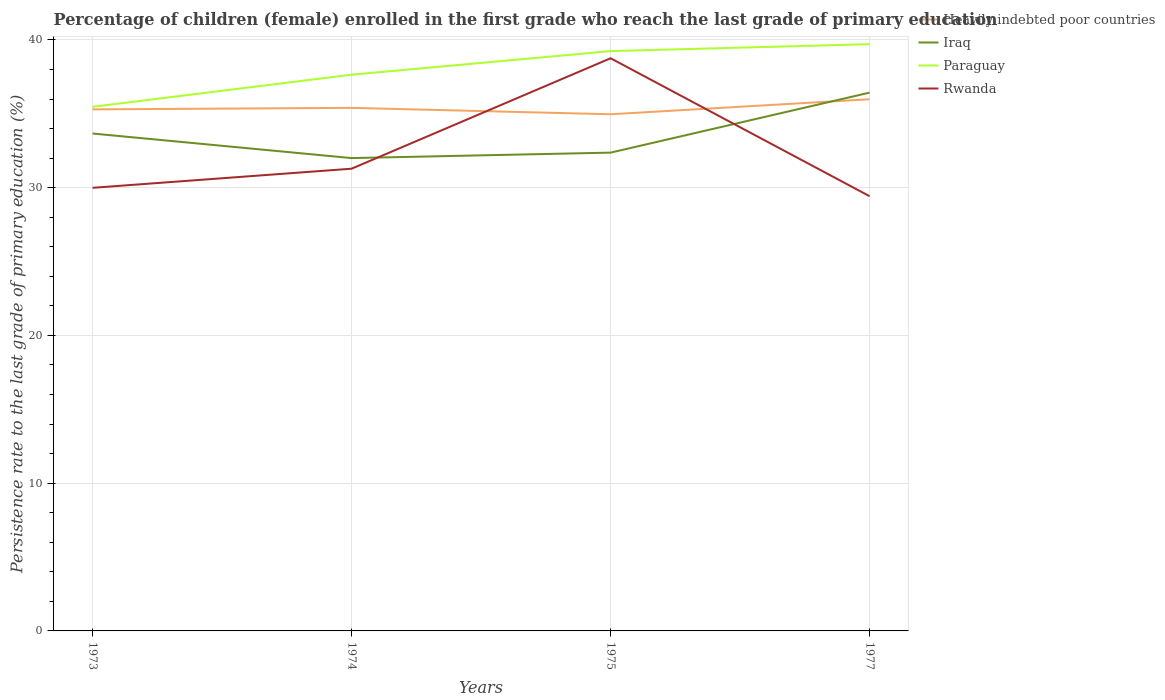Does the line corresponding to Iraq intersect with the line corresponding to Paraguay?
Offer a very short reply. No. Across all years, what is the maximum persistence rate of children in Paraguay?
Keep it short and to the point. 35.47. In which year was the persistence rate of children in Iraq maximum?
Your answer should be compact. 1974. What is the total persistence rate of children in Paraguay in the graph?
Ensure brevity in your answer.  -2.06. What is the difference between the highest and the second highest persistence rate of children in Iraq?
Your response must be concise. 4.43. Is the persistence rate of children in Rwanda strictly greater than the persistence rate of children in Iraq over the years?
Provide a succinct answer. No. Are the values on the major ticks of Y-axis written in scientific E-notation?
Keep it short and to the point. No. Does the graph contain grids?
Your answer should be very brief. Yes. Where does the legend appear in the graph?
Ensure brevity in your answer.  Top right. How are the legend labels stacked?
Make the answer very short. Vertical. What is the title of the graph?
Your answer should be compact. Percentage of children (female) enrolled in the first grade who reach the last grade of primary education. Does "Arab World" appear as one of the legend labels in the graph?
Offer a terse response. No. What is the label or title of the X-axis?
Provide a succinct answer. Years. What is the label or title of the Y-axis?
Ensure brevity in your answer.  Persistence rate to the last grade of primary education (%). What is the Persistence rate to the last grade of primary education (%) of Heavily indebted poor countries in 1973?
Offer a very short reply. 35.3. What is the Persistence rate to the last grade of primary education (%) of Iraq in 1973?
Provide a short and direct response. 33.66. What is the Persistence rate to the last grade of primary education (%) in Paraguay in 1973?
Offer a very short reply. 35.47. What is the Persistence rate to the last grade of primary education (%) of Rwanda in 1973?
Make the answer very short. 29.99. What is the Persistence rate to the last grade of primary education (%) of Heavily indebted poor countries in 1974?
Offer a terse response. 35.4. What is the Persistence rate to the last grade of primary education (%) in Iraq in 1974?
Provide a short and direct response. 32. What is the Persistence rate to the last grade of primary education (%) of Paraguay in 1974?
Give a very brief answer. 37.65. What is the Persistence rate to the last grade of primary education (%) of Rwanda in 1974?
Keep it short and to the point. 31.28. What is the Persistence rate to the last grade of primary education (%) of Heavily indebted poor countries in 1975?
Offer a very short reply. 34.97. What is the Persistence rate to the last grade of primary education (%) of Iraq in 1975?
Keep it short and to the point. 32.37. What is the Persistence rate to the last grade of primary education (%) in Paraguay in 1975?
Your response must be concise. 39.24. What is the Persistence rate to the last grade of primary education (%) in Rwanda in 1975?
Ensure brevity in your answer.  38.76. What is the Persistence rate to the last grade of primary education (%) of Heavily indebted poor countries in 1977?
Provide a short and direct response. 35.98. What is the Persistence rate to the last grade of primary education (%) in Iraq in 1977?
Your response must be concise. 36.43. What is the Persistence rate to the last grade of primary education (%) in Paraguay in 1977?
Your answer should be compact. 39.71. What is the Persistence rate to the last grade of primary education (%) in Rwanda in 1977?
Ensure brevity in your answer.  29.42. Across all years, what is the maximum Persistence rate to the last grade of primary education (%) in Heavily indebted poor countries?
Keep it short and to the point. 35.98. Across all years, what is the maximum Persistence rate to the last grade of primary education (%) in Iraq?
Your answer should be compact. 36.43. Across all years, what is the maximum Persistence rate to the last grade of primary education (%) in Paraguay?
Make the answer very short. 39.71. Across all years, what is the maximum Persistence rate to the last grade of primary education (%) in Rwanda?
Keep it short and to the point. 38.76. Across all years, what is the minimum Persistence rate to the last grade of primary education (%) in Heavily indebted poor countries?
Make the answer very short. 34.97. Across all years, what is the minimum Persistence rate to the last grade of primary education (%) in Iraq?
Your answer should be compact. 32. Across all years, what is the minimum Persistence rate to the last grade of primary education (%) of Paraguay?
Keep it short and to the point. 35.47. Across all years, what is the minimum Persistence rate to the last grade of primary education (%) of Rwanda?
Keep it short and to the point. 29.42. What is the total Persistence rate to the last grade of primary education (%) of Heavily indebted poor countries in the graph?
Provide a succinct answer. 141.65. What is the total Persistence rate to the last grade of primary education (%) of Iraq in the graph?
Make the answer very short. 134.47. What is the total Persistence rate to the last grade of primary education (%) of Paraguay in the graph?
Provide a succinct answer. 152.07. What is the total Persistence rate to the last grade of primary education (%) in Rwanda in the graph?
Provide a succinct answer. 129.45. What is the difference between the Persistence rate to the last grade of primary education (%) of Heavily indebted poor countries in 1973 and that in 1974?
Your answer should be compact. -0.1. What is the difference between the Persistence rate to the last grade of primary education (%) of Iraq in 1973 and that in 1974?
Provide a succinct answer. 1.66. What is the difference between the Persistence rate to the last grade of primary education (%) of Paraguay in 1973 and that in 1974?
Keep it short and to the point. -2.18. What is the difference between the Persistence rate to the last grade of primary education (%) of Rwanda in 1973 and that in 1974?
Make the answer very short. -1.29. What is the difference between the Persistence rate to the last grade of primary education (%) of Heavily indebted poor countries in 1973 and that in 1975?
Make the answer very short. 0.33. What is the difference between the Persistence rate to the last grade of primary education (%) in Iraq in 1973 and that in 1975?
Provide a succinct answer. 1.29. What is the difference between the Persistence rate to the last grade of primary education (%) of Paraguay in 1973 and that in 1975?
Offer a terse response. -3.77. What is the difference between the Persistence rate to the last grade of primary education (%) in Rwanda in 1973 and that in 1975?
Your response must be concise. -8.77. What is the difference between the Persistence rate to the last grade of primary education (%) in Heavily indebted poor countries in 1973 and that in 1977?
Your answer should be very brief. -0.69. What is the difference between the Persistence rate to the last grade of primary education (%) in Iraq in 1973 and that in 1977?
Provide a short and direct response. -2.77. What is the difference between the Persistence rate to the last grade of primary education (%) in Paraguay in 1973 and that in 1977?
Provide a short and direct response. -4.24. What is the difference between the Persistence rate to the last grade of primary education (%) in Rwanda in 1973 and that in 1977?
Make the answer very short. 0.57. What is the difference between the Persistence rate to the last grade of primary education (%) in Heavily indebted poor countries in 1974 and that in 1975?
Your answer should be compact. 0.43. What is the difference between the Persistence rate to the last grade of primary education (%) of Iraq in 1974 and that in 1975?
Give a very brief answer. -0.37. What is the difference between the Persistence rate to the last grade of primary education (%) in Paraguay in 1974 and that in 1975?
Offer a very short reply. -1.59. What is the difference between the Persistence rate to the last grade of primary education (%) of Rwanda in 1974 and that in 1975?
Provide a short and direct response. -7.47. What is the difference between the Persistence rate to the last grade of primary education (%) in Heavily indebted poor countries in 1974 and that in 1977?
Offer a terse response. -0.58. What is the difference between the Persistence rate to the last grade of primary education (%) in Iraq in 1974 and that in 1977?
Provide a succinct answer. -4.43. What is the difference between the Persistence rate to the last grade of primary education (%) in Paraguay in 1974 and that in 1977?
Provide a succinct answer. -2.06. What is the difference between the Persistence rate to the last grade of primary education (%) in Rwanda in 1974 and that in 1977?
Provide a succinct answer. 1.86. What is the difference between the Persistence rate to the last grade of primary education (%) of Heavily indebted poor countries in 1975 and that in 1977?
Provide a short and direct response. -1.02. What is the difference between the Persistence rate to the last grade of primary education (%) of Iraq in 1975 and that in 1977?
Keep it short and to the point. -4.06. What is the difference between the Persistence rate to the last grade of primary education (%) of Paraguay in 1975 and that in 1977?
Give a very brief answer. -0.47. What is the difference between the Persistence rate to the last grade of primary education (%) of Rwanda in 1975 and that in 1977?
Provide a short and direct response. 9.34. What is the difference between the Persistence rate to the last grade of primary education (%) in Heavily indebted poor countries in 1973 and the Persistence rate to the last grade of primary education (%) in Iraq in 1974?
Offer a terse response. 3.3. What is the difference between the Persistence rate to the last grade of primary education (%) of Heavily indebted poor countries in 1973 and the Persistence rate to the last grade of primary education (%) of Paraguay in 1974?
Make the answer very short. -2.35. What is the difference between the Persistence rate to the last grade of primary education (%) in Heavily indebted poor countries in 1973 and the Persistence rate to the last grade of primary education (%) in Rwanda in 1974?
Give a very brief answer. 4.02. What is the difference between the Persistence rate to the last grade of primary education (%) of Iraq in 1973 and the Persistence rate to the last grade of primary education (%) of Paraguay in 1974?
Your answer should be very brief. -3.98. What is the difference between the Persistence rate to the last grade of primary education (%) of Iraq in 1973 and the Persistence rate to the last grade of primary education (%) of Rwanda in 1974?
Provide a short and direct response. 2.38. What is the difference between the Persistence rate to the last grade of primary education (%) in Paraguay in 1973 and the Persistence rate to the last grade of primary education (%) in Rwanda in 1974?
Your answer should be very brief. 4.19. What is the difference between the Persistence rate to the last grade of primary education (%) in Heavily indebted poor countries in 1973 and the Persistence rate to the last grade of primary education (%) in Iraq in 1975?
Make the answer very short. 2.93. What is the difference between the Persistence rate to the last grade of primary education (%) of Heavily indebted poor countries in 1973 and the Persistence rate to the last grade of primary education (%) of Paraguay in 1975?
Give a very brief answer. -3.94. What is the difference between the Persistence rate to the last grade of primary education (%) in Heavily indebted poor countries in 1973 and the Persistence rate to the last grade of primary education (%) in Rwanda in 1975?
Offer a very short reply. -3.46. What is the difference between the Persistence rate to the last grade of primary education (%) in Iraq in 1973 and the Persistence rate to the last grade of primary education (%) in Paraguay in 1975?
Ensure brevity in your answer.  -5.58. What is the difference between the Persistence rate to the last grade of primary education (%) of Iraq in 1973 and the Persistence rate to the last grade of primary education (%) of Rwanda in 1975?
Give a very brief answer. -5.09. What is the difference between the Persistence rate to the last grade of primary education (%) of Paraguay in 1973 and the Persistence rate to the last grade of primary education (%) of Rwanda in 1975?
Offer a very short reply. -3.29. What is the difference between the Persistence rate to the last grade of primary education (%) of Heavily indebted poor countries in 1973 and the Persistence rate to the last grade of primary education (%) of Iraq in 1977?
Ensure brevity in your answer.  -1.13. What is the difference between the Persistence rate to the last grade of primary education (%) of Heavily indebted poor countries in 1973 and the Persistence rate to the last grade of primary education (%) of Paraguay in 1977?
Provide a succinct answer. -4.41. What is the difference between the Persistence rate to the last grade of primary education (%) in Heavily indebted poor countries in 1973 and the Persistence rate to the last grade of primary education (%) in Rwanda in 1977?
Provide a short and direct response. 5.88. What is the difference between the Persistence rate to the last grade of primary education (%) in Iraq in 1973 and the Persistence rate to the last grade of primary education (%) in Paraguay in 1977?
Offer a very short reply. -6.05. What is the difference between the Persistence rate to the last grade of primary education (%) of Iraq in 1973 and the Persistence rate to the last grade of primary education (%) of Rwanda in 1977?
Your answer should be very brief. 4.24. What is the difference between the Persistence rate to the last grade of primary education (%) of Paraguay in 1973 and the Persistence rate to the last grade of primary education (%) of Rwanda in 1977?
Keep it short and to the point. 6.05. What is the difference between the Persistence rate to the last grade of primary education (%) of Heavily indebted poor countries in 1974 and the Persistence rate to the last grade of primary education (%) of Iraq in 1975?
Make the answer very short. 3.03. What is the difference between the Persistence rate to the last grade of primary education (%) in Heavily indebted poor countries in 1974 and the Persistence rate to the last grade of primary education (%) in Paraguay in 1975?
Provide a succinct answer. -3.84. What is the difference between the Persistence rate to the last grade of primary education (%) of Heavily indebted poor countries in 1974 and the Persistence rate to the last grade of primary education (%) of Rwanda in 1975?
Offer a very short reply. -3.36. What is the difference between the Persistence rate to the last grade of primary education (%) in Iraq in 1974 and the Persistence rate to the last grade of primary education (%) in Paraguay in 1975?
Make the answer very short. -7.24. What is the difference between the Persistence rate to the last grade of primary education (%) of Iraq in 1974 and the Persistence rate to the last grade of primary education (%) of Rwanda in 1975?
Your answer should be compact. -6.76. What is the difference between the Persistence rate to the last grade of primary education (%) of Paraguay in 1974 and the Persistence rate to the last grade of primary education (%) of Rwanda in 1975?
Provide a succinct answer. -1.11. What is the difference between the Persistence rate to the last grade of primary education (%) of Heavily indebted poor countries in 1974 and the Persistence rate to the last grade of primary education (%) of Iraq in 1977?
Your response must be concise. -1.03. What is the difference between the Persistence rate to the last grade of primary education (%) in Heavily indebted poor countries in 1974 and the Persistence rate to the last grade of primary education (%) in Paraguay in 1977?
Provide a succinct answer. -4.31. What is the difference between the Persistence rate to the last grade of primary education (%) of Heavily indebted poor countries in 1974 and the Persistence rate to the last grade of primary education (%) of Rwanda in 1977?
Your response must be concise. 5.98. What is the difference between the Persistence rate to the last grade of primary education (%) in Iraq in 1974 and the Persistence rate to the last grade of primary education (%) in Paraguay in 1977?
Offer a terse response. -7.71. What is the difference between the Persistence rate to the last grade of primary education (%) in Iraq in 1974 and the Persistence rate to the last grade of primary education (%) in Rwanda in 1977?
Your answer should be very brief. 2.58. What is the difference between the Persistence rate to the last grade of primary education (%) of Paraguay in 1974 and the Persistence rate to the last grade of primary education (%) of Rwanda in 1977?
Provide a short and direct response. 8.22. What is the difference between the Persistence rate to the last grade of primary education (%) in Heavily indebted poor countries in 1975 and the Persistence rate to the last grade of primary education (%) in Iraq in 1977?
Make the answer very short. -1.47. What is the difference between the Persistence rate to the last grade of primary education (%) in Heavily indebted poor countries in 1975 and the Persistence rate to the last grade of primary education (%) in Paraguay in 1977?
Keep it short and to the point. -4.74. What is the difference between the Persistence rate to the last grade of primary education (%) of Heavily indebted poor countries in 1975 and the Persistence rate to the last grade of primary education (%) of Rwanda in 1977?
Give a very brief answer. 5.55. What is the difference between the Persistence rate to the last grade of primary education (%) in Iraq in 1975 and the Persistence rate to the last grade of primary education (%) in Paraguay in 1977?
Provide a succinct answer. -7.34. What is the difference between the Persistence rate to the last grade of primary education (%) of Iraq in 1975 and the Persistence rate to the last grade of primary education (%) of Rwanda in 1977?
Offer a terse response. 2.95. What is the difference between the Persistence rate to the last grade of primary education (%) of Paraguay in 1975 and the Persistence rate to the last grade of primary education (%) of Rwanda in 1977?
Your answer should be very brief. 9.82. What is the average Persistence rate to the last grade of primary education (%) in Heavily indebted poor countries per year?
Give a very brief answer. 35.41. What is the average Persistence rate to the last grade of primary education (%) of Iraq per year?
Make the answer very short. 33.62. What is the average Persistence rate to the last grade of primary education (%) in Paraguay per year?
Provide a succinct answer. 38.02. What is the average Persistence rate to the last grade of primary education (%) in Rwanda per year?
Provide a short and direct response. 32.36. In the year 1973, what is the difference between the Persistence rate to the last grade of primary education (%) in Heavily indebted poor countries and Persistence rate to the last grade of primary education (%) in Iraq?
Provide a short and direct response. 1.63. In the year 1973, what is the difference between the Persistence rate to the last grade of primary education (%) of Heavily indebted poor countries and Persistence rate to the last grade of primary education (%) of Paraguay?
Offer a terse response. -0.17. In the year 1973, what is the difference between the Persistence rate to the last grade of primary education (%) of Heavily indebted poor countries and Persistence rate to the last grade of primary education (%) of Rwanda?
Ensure brevity in your answer.  5.31. In the year 1973, what is the difference between the Persistence rate to the last grade of primary education (%) of Iraq and Persistence rate to the last grade of primary education (%) of Paraguay?
Keep it short and to the point. -1.81. In the year 1973, what is the difference between the Persistence rate to the last grade of primary education (%) in Iraq and Persistence rate to the last grade of primary education (%) in Rwanda?
Your answer should be very brief. 3.67. In the year 1973, what is the difference between the Persistence rate to the last grade of primary education (%) in Paraguay and Persistence rate to the last grade of primary education (%) in Rwanda?
Provide a succinct answer. 5.48. In the year 1974, what is the difference between the Persistence rate to the last grade of primary education (%) in Heavily indebted poor countries and Persistence rate to the last grade of primary education (%) in Iraq?
Ensure brevity in your answer.  3.4. In the year 1974, what is the difference between the Persistence rate to the last grade of primary education (%) in Heavily indebted poor countries and Persistence rate to the last grade of primary education (%) in Paraguay?
Your answer should be very brief. -2.25. In the year 1974, what is the difference between the Persistence rate to the last grade of primary education (%) of Heavily indebted poor countries and Persistence rate to the last grade of primary education (%) of Rwanda?
Provide a short and direct response. 4.12. In the year 1974, what is the difference between the Persistence rate to the last grade of primary education (%) of Iraq and Persistence rate to the last grade of primary education (%) of Paraguay?
Offer a terse response. -5.64. In the year 1974, what is the difference between the Persistence rate to the last grade of primary education (%) of Iraq and Persistence rate to the last grade of primary education (%) of Rwanda?
Offer a very short reply. 0.72. In the year 1974, what is the difference between the Persistence rate to the last grade of primary education (%) of Paraguay and Persistence rate to the last grade of primary education (%) of Rwanda?
Offer a very short reply. 6.36. In the year 1975, what is the difference between the Persistence rate to the last grade of primary education (%) of Heavily indebted poor countries and Persistence rate to the last grade of primary education (%) of Iraq?
Provide a short and direct response. 2.6. In the year 1975, what is the difference between the Persistence rate to the last grade of primary education (%) of Heavily indebted poor countries and Persistence rate to the last grade of primary education (%) of Paraguay?
Keep it short and to the point. -4.27. In the year 1975, what is the difference between the Persistence rate to the last grade of primary education (%) in Heavily indebted poor countries and Persistence rate to the last grade of primary education (%) in Rwanda?
Your answer should be compact. -3.79. In the year 1975, what is the difference between the Persistence rate to the last grade of primary education (%) of Iraq and Persistence rate to the last grade of primary education (%) of Paraguay?
Your answer should be compact. -6.87. In the year 1975, what is the difference between the Persistence rate to the last grade of primary education (%) in Iraq and Persistence rate to the last grade of primary education (%) in Rwanda?
Give a very brief answer. -6.39. In the year 1975, what is the difference between the Persistence rate to the last grade of primary education (%) of Paraguay and Persistence rate to the last grade of primary education (%) of Rwanda?
Your answer should be very brief. 0.48. In the year 1977, what is the difference between the Persistence rate to the last grade of primary education (%) in Heavily indebted poor countries and Persistence rate to the last grade of primary education (%) in Iraq?
Provide a succinct answer. -0.45. In the year 1977, what is the difference between the Persistence rate to the last grade of primary education (%) of Heavily indebted poor countries and Persistence rate to the last grade of primary education (%) of Paraguay?
Your answer should be compact. -3.73. In the year 1977, what is the difference between the Persistence rate to the last grade of primary education (%) of Heavily indebted poor countries and Persistence rate to the last grade of primary education (%) of Rwanda?
Offer a terse response. 6.56. In the year 1977, what is the difference between the Persistence rate to the last grade of primary education (%) of Iraq and Persistence rate to the last grade of primary education (%) of Paraguay?
Offer a very short reply. -3.28. In the year 1977, what is the difference between the Persistence rate to the last grade of primary education (%) in Iraq and Persistence rate to the last grade of primary education (%) in Rwanda?
Offer a terse response. 7.01. In the year 1977, what is the difference between the Persistence rate to the last grade of primary education (%) of Paraguay and Persistence rate to the last grade of primary education (%) of Rwanda?
Offer a very short reply. 10.29. What is the ratio of the Persistence rate to the last grade of primary education (%) in Heavily indebted poor countries in 1973 to that in 1974?
Provide a succinct answer. 1. What is the ratio of the Persistence rate to the last grade of primary education (%) in Iraq in 1973 to that in 1974?
Give a very brief answer. 1.05. What is the ratio of the Persistence rate to the last grade of primary education (%) in Paraguay in 1973 to that in 1974?
Ensure brevity in your answer.  0.94. What is the ratio of the Persistence rate to the last grade of primary education (%) of Rwanda in 1973 to that in 1974?
Your answer should be compact. 0.96. What is the ratio of the Persistence rate to the last grade of primary education (%) of Heavily indebted poor countries in 1973 to that in 1975?
Offer a terse response. 1.01. What is the ratio of the Persistence rate to the last grade of primary education (%) in Paraguay in 1973 to that in 1975?
Offer a terse response. 0.9. What is the ratio of the Persistence rate to the last grade of primary education (%) in Rwanda in 1973 to that in 1975?
Ensure brevity in your answer.  0.77. What is the ratio of the Persistence rate to the last grade of primary education (%) in Heavily indebted poor countries in 1973 to that in 1977?
Your answer should be compact. 0.98. What is the ratio of the Persistence rate to the last grade of primary education (%) of Iraq in 1973 to that in 1977?
Give a very brief answer. 0.92. What is the ratio of the Persistence rate to the last grade of primary education (%) of Paraguay in 1973 to that in 1977?
Your answer should be compact. 0.89. What is the ratio of the Persistence rate to the last grade of primary education (%) of Rwanda in 1973 to that in 1977?
Your response must be concise. 1.02. What is the ratio of the Persistence rate to the last grade of primary education (%) in Heavily indebted poor countries in 1974 to that in 1975?
Offer a very short reply. 1.01. What is the ratio of the Persistence rate to the last grade of primary education (%) in Paraguay in 1974 to that in 1975?
Make the answer very short. 0.96. What is the ratio of the Persistence rate to the last grade of primary education (%) in Rwanda in 1974 to that in 1975?
Provide a succinct answer. 0.81. What is the ratio of the Persistence rate to the last grade of primary education (%) of Heavily indebted poor countries in 1974 to that in 1977?
Your answer should be compact. 0.98. What is the ratio of the Persistence rate to the last grade of primary education (%) of Iraq in 1974 to that in 1977?
Keep it short and to the point. 0.88. What is the ratio of the Persistence rate to the last grade of primary education (%) in Paraguay in 1974 to that in 1977?
Your answer should be very brief. 0.95. What is the ratio of the Persistence rate to the last grade of primary education (%) of Rwanda in 1974 to that in 1977?
Offer a terse response. 1.06. What is the ratio of the Persistence rate to the last grade of primary education (%) of Heavily indebted poor countries in 1975 to that in 1977?
Offer a terse response. 0.97. What is the ratio of the Persistence rate to the last grade of primary education (%) in Iraq in 1975 to that in 1977?
Make the answer very short. 0.89. What is the ratio of the Persistence rate to the last grade of primary education (%) of Rwanda in 1975 to that in 1977?
Provide a short and direct response. 1.32. What is the difference between the highest and the second highest Persistence rate to the last grade of primary education (%) of Heavily indebted poor countries?
Offer a very short reply. 0.58. What is the difference between the highest and the second highest Persistence rate to the last grade of primary education (%) in Iraq?
Provide a succinct answer. 2.77. What is the difference between the highest and the second highest Persistence rate to the last grade of primary education (%) in Paraguay?
Offer a terse response. 0.47. What is the difference between the highest and the second highest Persistence rate to the last grade of primary education (%) of Rwanda?
Your response must be concise. 7.47. What is the difference between the highest and the lowest Persistence rate to the last grade of primary education (%) of Heavily indebted poor countries?
Make the answer very short. 1.02. What is the difference between the highest and the lowest Persistence rate to the last grade of primary education (%) of Iraq?
Offer a very short reply. 4.43. What is the difference between the highest and the lowest Persistence rate to the last grade of primary education (%) of Paraguay?
Provide a short and direct response. 4.24. What is the difference between the highest and the lowest Persistence rate to the last grade of primary education (%) of Rwanda?
Give a very brief answer. 9.34. 